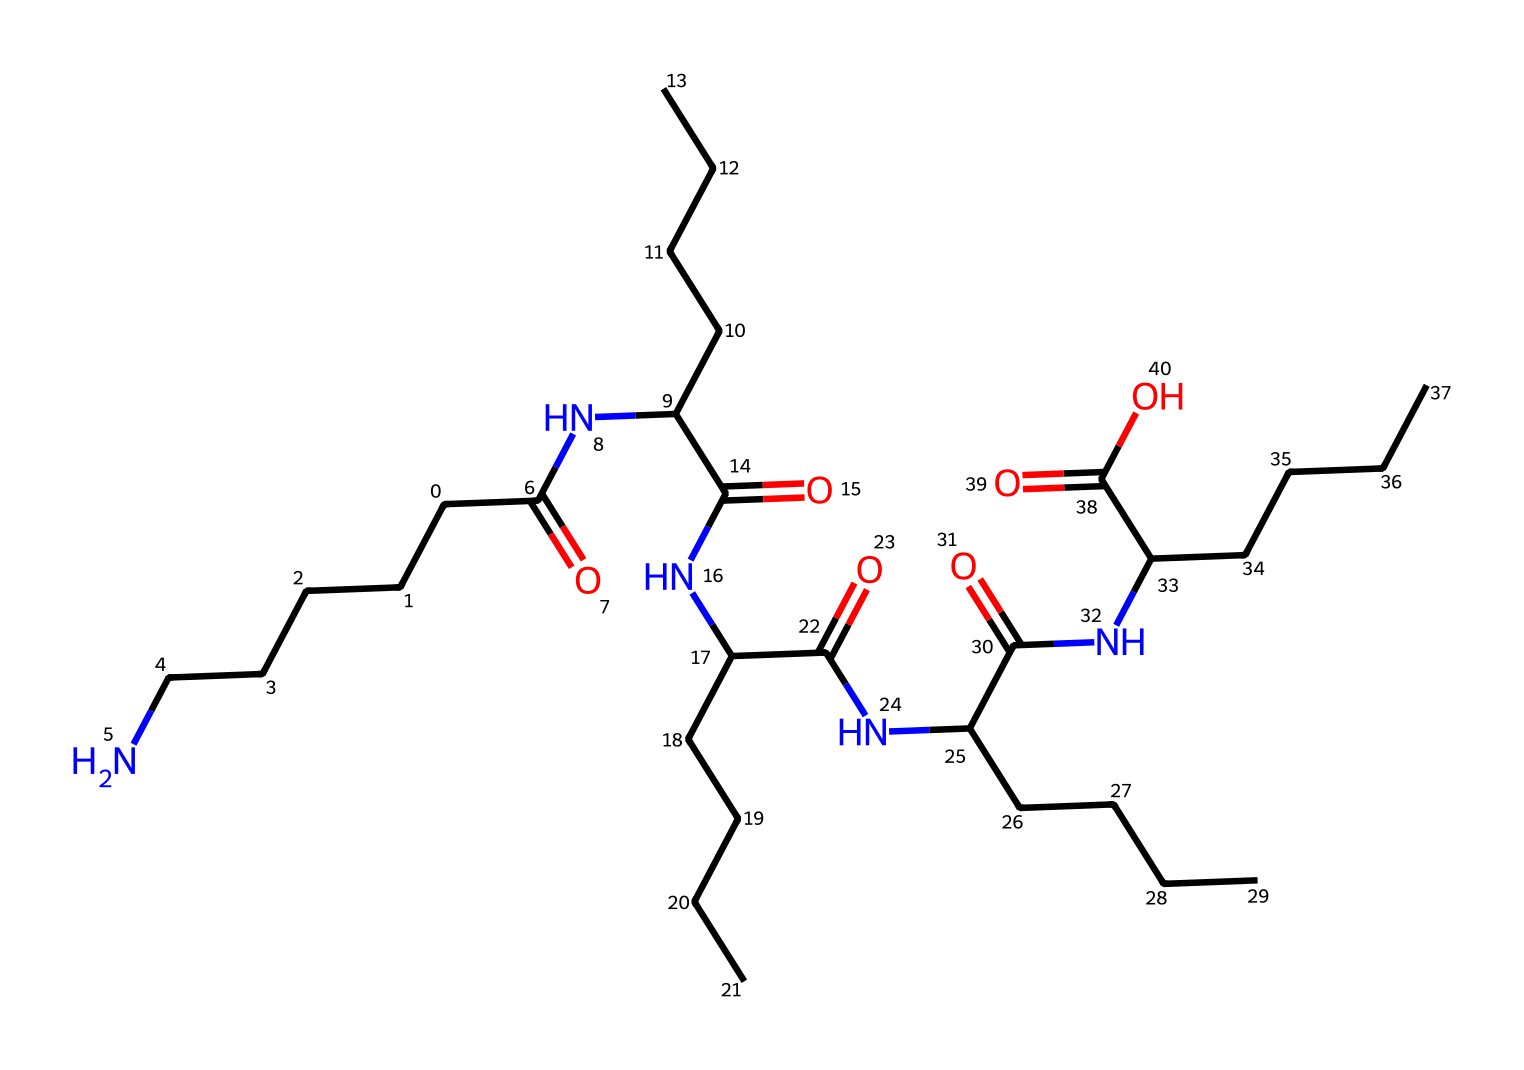what is the main type of polymer represented by this structure? The structure shows repeated amide linkages (-C(=O)N-) and long hydrocarbon chains, which are characteristic of polyamides. Thus, this chemical is a polyamide.
Answer: polyamide how many carbon atoms are present in the structure? By analyzing the SMILES representation, there are 30 carbon atoms distributed throughout the long chains in the molecular structure.
Answer: 30 how many amide linkages are present? In the SMILES representation, there are a total of five occurrences of the amide functional group (-C(=O)N-), indicating five amide linkages.
Answer: 5 what is the significance of the C(=O)O group in the structure? The presence of the carboxylic acid group (-C(=O)O) suggests that this polymer can participate in hydrogen bonding, which contributes to its physical properties such as melting point and solubility.
Answer: hydrogen bonding what type of properties does nylon 6,6 generally exhibit due to its structure? The structure indicates a high degree of crystallinity and strength due to its linear arrangement and hydrogen bonding capabilities. This results in characteristics like high tensile strength, durability, and resistance to abrasion.
Answer: strength and durability 